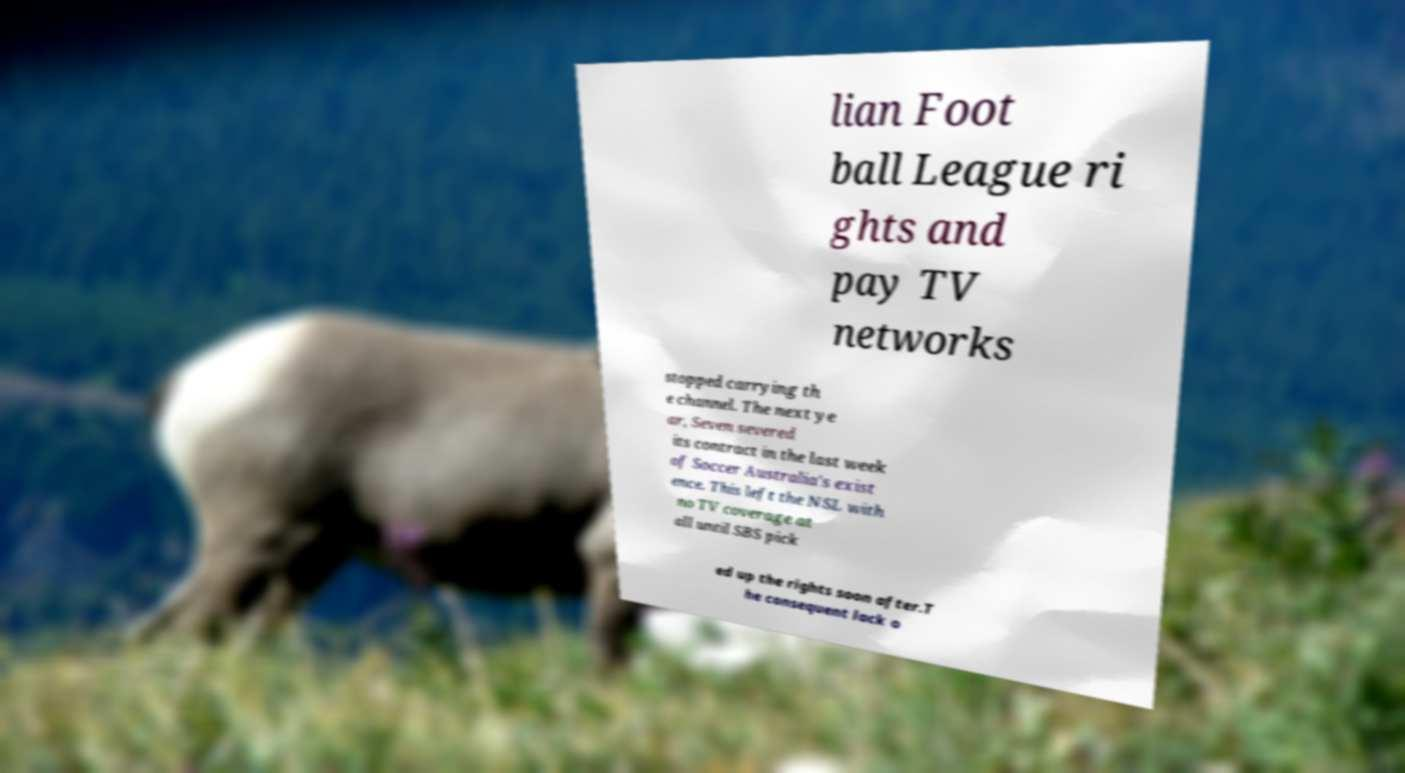Please identify and transcribe the text found in this image. lian Foot ball League ri ghts and pay TV networks stopped carrying th e channel. The next ye ar, Seven severed its contract in the last week of Soccer Australia's exist ence. This left the NSL with no TV coverage at all until SBS pick ed up the rights soon after.T he consequent lack o 